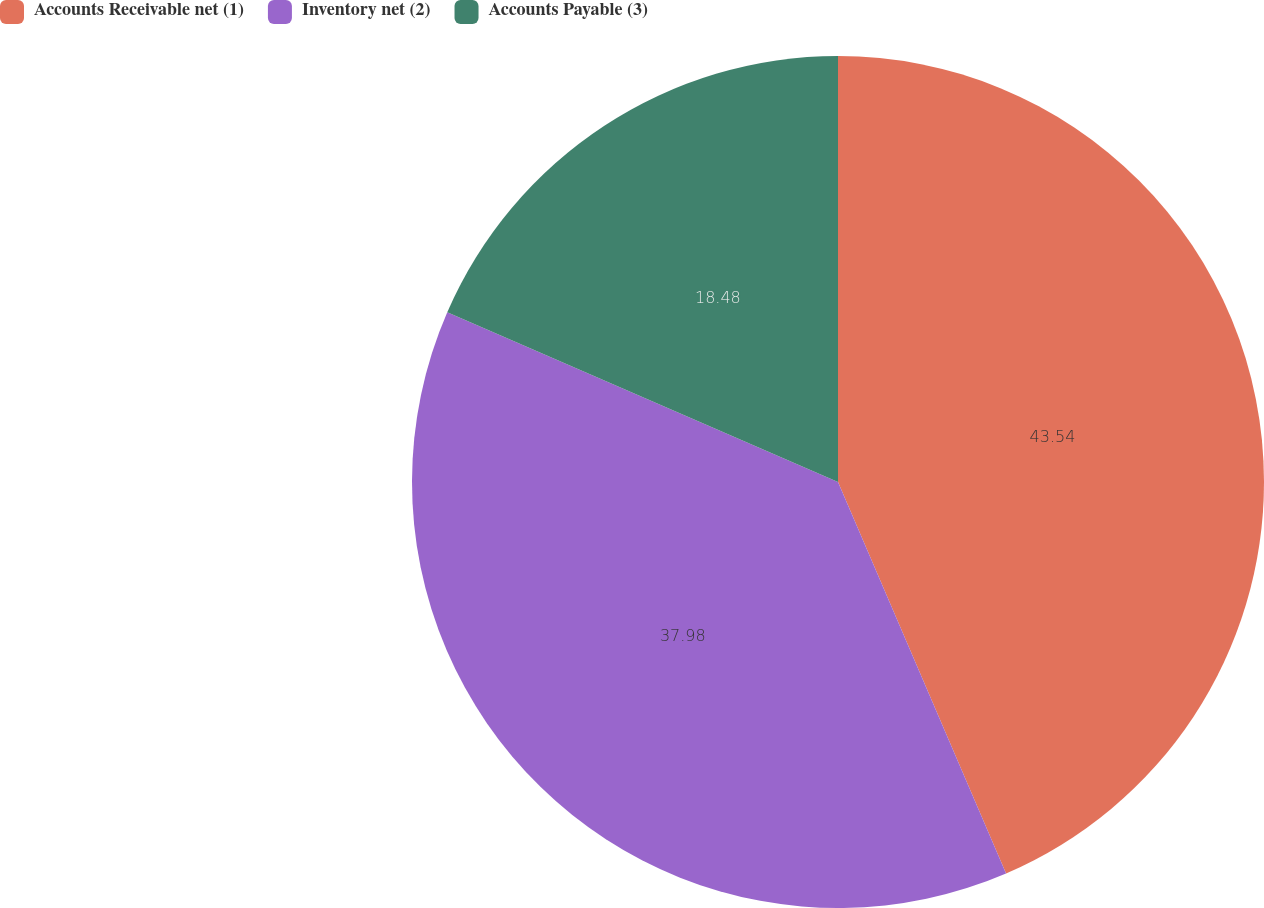<chart> <loc_0><loc_0><loc_500><loc_500><pie_chart><fcel>Accounts Receivable net (1)<fcel>Inventory net (2)<fcel>Accounts Payable (3)<nl><fcel>43.55%<fcel>37.98%<fcel>18.48%<nl></chart> 